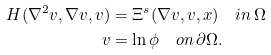<formula> <loc_0><loc_0><loc_500><loc_500>H ( \nabla ^ { 2 } v , \nabla v , v ) & = \Xi ^ { s } ( \nabla v , v , x ) \quad i n \, \Omega \\ v & = \ln \phi \quad o n \, \partial \Omega .</formula> 